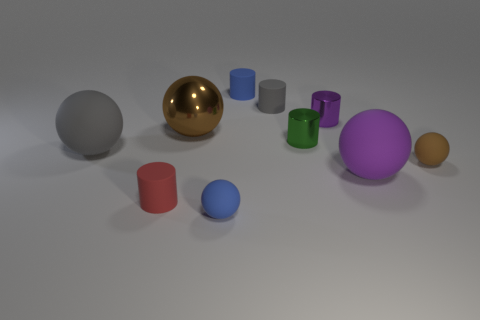Does the tiny blue ball have the same material as the big purple ball?
Keep it short and to the point. Yes. Are there an equal number of brown things that are in front of the big gray object and blue objects?
Ensure brevity in your answer.  No. What number of tiny purple spheres have the same material as the small green cylinder?
Ensure brevity in your answer.  0. Is the number of small blue rubber objects less than the number of tiny brown matte spheres?
Provide a succinct answer. No. Is the color of the tiny matte sphere that is behind the small red matte cylinder the same as the big metal thing?
Keep it short and to the point. Yes. What number of blue matte things are to the right of the blue thing that is behind the large matte ball right of the large gray matte object?
Your answer should be compact. 0. There is a purple shiny thing; what number of spheres are right of it?
Provide a short and direct response. 2. There is a metallic thing that is the same shape as the purple rubber object; what is its color?
Your response must be concise. Brown. What material is the cylinder that is in front of the purple metal cylinder and right of the big brown sphere?
Provide a short and direct response. Metal. Does the shiny object that is left of the gray rubber cylinder have the same size as the tiny purple cylinder?
Offer a very short reply. No. 